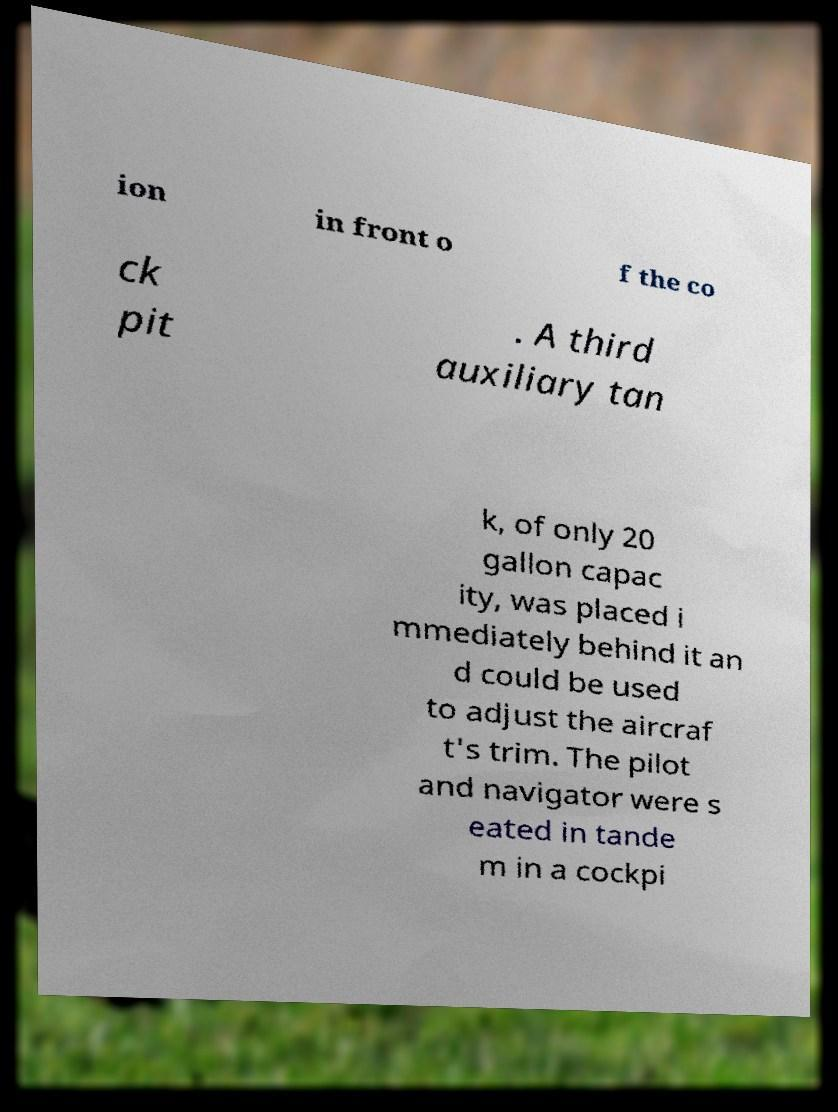I need the written content from this picture converted into text. Can you do that? ion in front o f the co ck pit . A third auxiliary tan k, of only 20 gallon capac ity, was placed i mmediately behind it an d could be used to adjust the aircraf t's trim. The pilot and navigator were s eated in tande m in a cockpi 